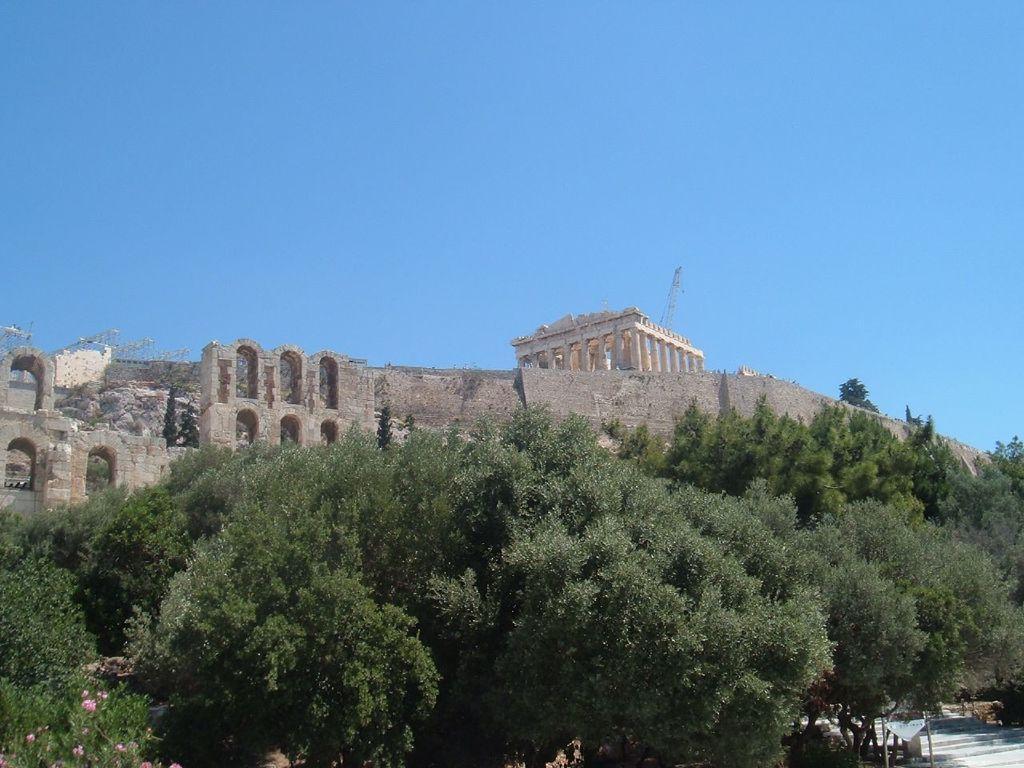Describe this image in one or two sentences. At the bottom of the picture, we see the trees and a plant which has pink flowers. In the right bottom, we see the staircase and a board or a banner in white color. In the background, we see a tower and the castle or the fort. At the top, we see the sky, which is blue in color. 